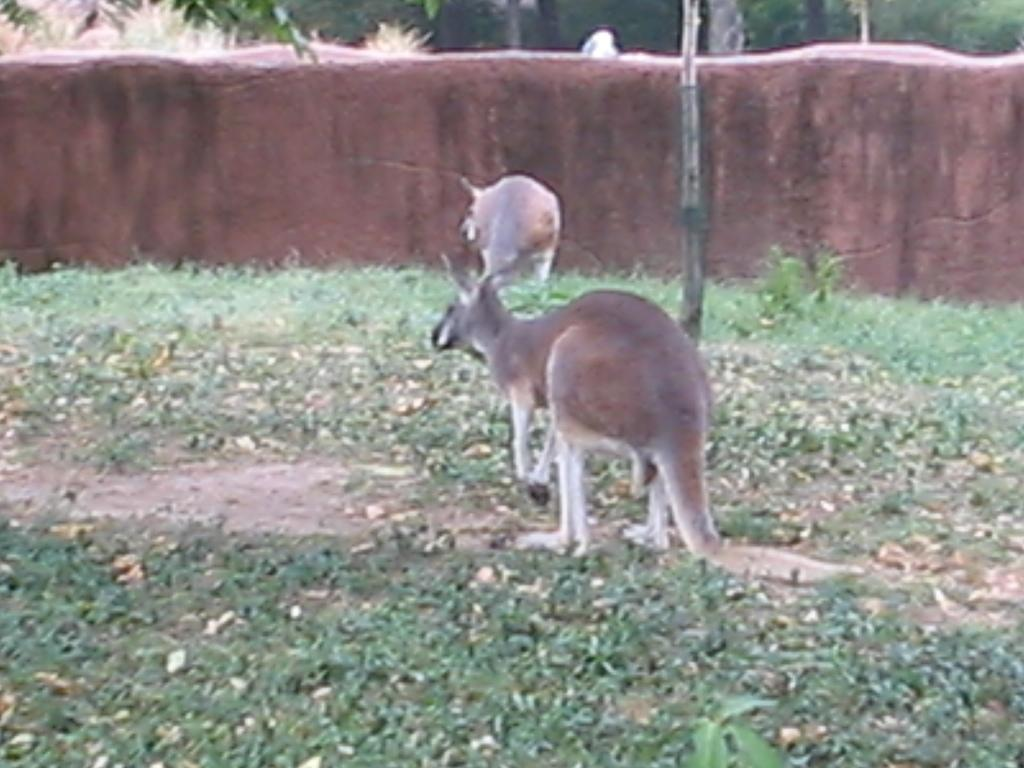What animal is present in the image? There is a kangaroo in the image. What type of surface is visible on the floor? There is grass on the floor in the image. What can be seen in the background of the image? There is a wall and trees in the background of the image. How would you describe the quality of the image? The image is blurred. What type of society is depicted in the image? There is no depiction of a society in the image; it features a kangaroo and a blurred background. 